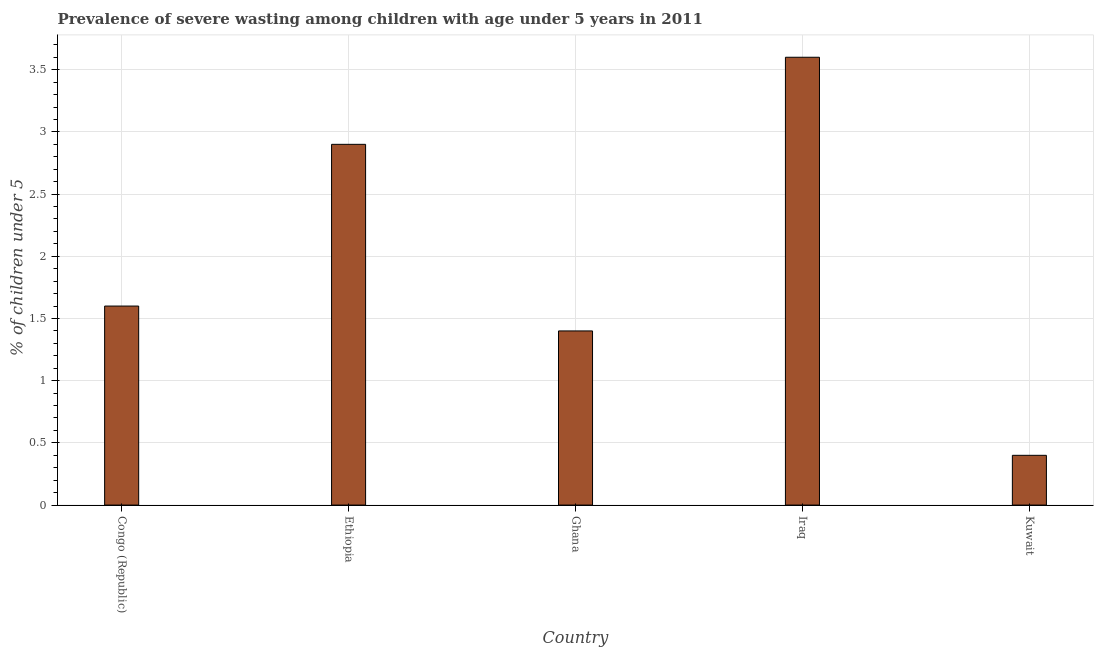Does the graph contain grids?
Give a very brief answer. Yes. What is the title of the graph?
Offer a terse response. Prevalence of severe wasting among children with age under 5 years in 2011. What is the label or title of the X-axis?
Your answer should be very brief. Country. What is the label or title of the Y-axis?
Provide a short and direct response.  % of children under 5. What is the prevalence of severe wasting in Iraq?
Your answer should be compact. 3.6. Across all countries, what is the maximum prevalence of severe wasting?
Provide a succinct answer. 3.6. Across all countries, what is the minimum prevalence of severe wasting?
Offer a terse response. 0.4. In which country was the prevalence of severe wasting maximum?
Keep it short and to the point. Iraq. In which country was the prevalence of severe wasting minimum?
Offer a very short reply. Kuwait. What is the sum of the prevalence of severe wasting?
Provide a short and direct response. 9.9. What is the average prevalence of severe wasting per country?
Offer a terse response. 1.98. What is the median prevalence of severe wasting?
Ensure brevity in your answer.  1.6. In how many countries, is the prevalence of severe wasting greater than 1 %?
Provide a short and direct response. 4. What is the ratio of the prevalence of severe wasting in Congo (Republic) to that in Iraq?
Provide a short and direct response. 0.44. Is the prevalence of severe wasting in Congo (Republic) less than that in Ethiopia?
Provide a succinct answer. Yes. Is the difference between the prevalence of severe wasting in Ghana and Kuwait greater than the difference between any two countries?
Your answer should be very brief. No. What is the difference between the highest and the lowest prevalence of severe wasting?
Ensure brevity in your answer.  3.2. In how many countries, is the prevalence of severe wasting greater than the average prevalence of severe wasting taken over all countries?
Your answer should be compact. 2. How many bars are there?
Provide a short and direct response. 5. Are all the bars in the graph horizontal?
Give a very brief answer. No. Are the values on the major ticks of Y-axis written in scientific E-notation?
Make the answer very short. No. What is the  % of children under 5 in Congo (Republic)?
Ensure brevity in your answer.  1.6. What is the  % of children under 5 in Ethiopia?
Keep it short and to the point. 2.9. What is the  % of children under 5 of Ghana?
Make the answer very short. 1.4. What is the  % of children under 5 of Iraq?
Your answer should be very brief. 3.6. What is the  % of children under 5 in Kuwait?
Ensure brevity in your answer.  0.4. What is the difference between the  % of children under 5 in Congo (Republic) and Ethiopia?
Make the answer very short. -1.3. What is the difference between the  % of children under 5 in Congo (Republic) and Kuwait?
Keep it short and to the point. 1.2. What is the difference between the  % of children under 5 in Ethiopia and Iraq?
Provide a short and direct response. -0.7. What is the difference between the  % of children under 5 in Ghana and Kuwait?
Your response must be concise. 1. What is the ratio of the  % of children under 5 in Congo (Republic) to that in Ethiopia?
Provide a short and direct response. 0.55. What is the ratio of the  % of children under 5 in Congo (Republic) to that in Ghana?
Make the answer very short. 1.14. What is the ratio of the  % of children under 5 in Congo (Republic) to that in Iraq?
Provide a short and direct response. 0.44. What is the ratio of the  % of children under 5 in Congo (Republic) to that in Kuwait?
Make the answer very short. 4. What is the ratio of the  % of children under 5 in Ethiopia to that in Ghana?
Your answer should be very brief. 2.07. What is the ratio of the  % of children under 5 in Ethiopia to that in Iraq?
Your response must be concise. 0.81. What is the ratio of the  % of children under 5 in Ethiopia to that in Kuwait?
Give a very brief answer. 7.25. What is the ratio of the  % of children under 5 in Ghana to that in Iraq?
Give a very brief answer. 0.39. What is the ratio of the  % of children under 5 in Ghana to that in Kuwait?
Offer a terse response. 3.5. 